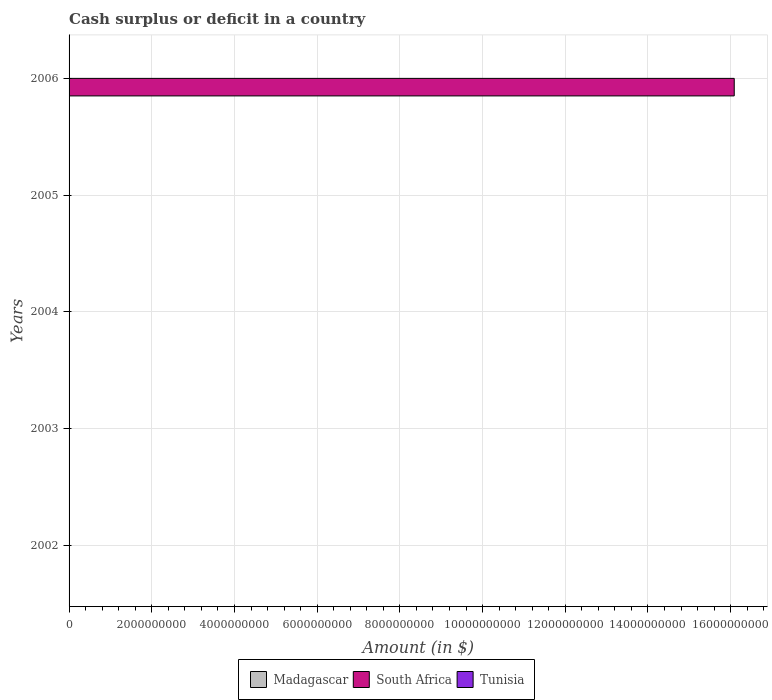How many different coloured bars are there?
Make the answer very short. 1. Are the number of bars on each tick of the Y-axis equal?
Ensure brevity in your answer.  No. What is the label of the 2nd group of bars from the top?
Your response must be concise. 2005. What is the amount of cash surplus or deficit in South Africa in 2002?
Make the answer very short. 0. Across all years, what is the minimum amount of cash surplus or deficit in Madagascar?
Your answer should be compact. 0. In which year was the amount of cash surplus or deficit in South Africa maximum?
Your answer should be very brief. 2006. What is the difference between the amount of cash surplus or deficit in Madagascar in 2004 and the amount of cash surplus or deficit in South Africa in 2003?
Provide a short and direct response. 0. In how many years, is the amount of cash surplus or deficit in Madagascar greater than 10400000000 $?
Offer a terse response. 0. What is the difference between the highest and the lowest amount of cash surplus or deficit in South Africa?
Offer a terse response. 1.61e+1. In how many years, is the amount of cash surplus or deficit in Tunisia greater than the average amount of cash surplus or deficit in Tunisia taken over all years?
Offer a very short reply. 0. Is it the case that in every year, the sum of the amount of cash surplus or deficit in Tunisia and amount of cash surplus or deficit in South Africa is greater than the amount of cash surplus or deficit in Madagascar?
Your response must be concise. No. How many years are there in the graph?
Offer a very short reply. 5. Are the values on the major ticks of X-axis written in scientific E-notation?
Give a very brief answer. No. Does the graph contain any zero values?
Make the answer very short. Yes. Does the graph contain grids?
Your answer should be compact. Yes. Where does the legend appear in the graph?
Provide a succinct answer. Bottom center. How many legend labels are there?
Provide a short and direct response. 3. What is the title of the graph?
Provide a short and direct response. Cash surplus or deficit in a country. Does "Nigeria" appear as one of the legend labels in the graph?
Provide a short and direct response. No. What is the label or title of the X-axis?
Provide a short and direct response. Amount (in $). What is the label or title of the Y-axis?
Your answer should be compact. Years. What is the Amount (in $) of South Africa in 2002?
Offer a very short reply. 0. What is the Amount (in $) in South Africa in 2004?
Your response must be concise. 0. What is the Amount (in $) of Tunisia in 2004?
Make the answer very short. 0. What is the Amount (in $) of Tunisia in 2005?
Offer a very short reply. 0. What is the Amount (in $) in South Africa in 2006?
Provide a succinct answer. 1.61e+1. What is the Amount (in $) of Tunisia in 2006?
Offer a very short reply. 0. Across all years, what is the maximum Amount (in $) in South Africa?
Keep it short and to the point. 1.61e+1. What is the total Amount (in $) of South Africa in the graph?
Make the answer very short. 1.61e+1. What is the average Amount (in $) of Madagascar per year?
Keep it short and to the point. 0. What is the average Amount (in $) of South Africa per year?
Give a very brief answer. 3.22e+09. What is the average Amount (in $) of Tunisia per year?
Provide a short and direct response. 0. What is the difference between the highest and the lowest Amount (in $) of South Africa?
Your answer should be very brief. 1.61e+1. 